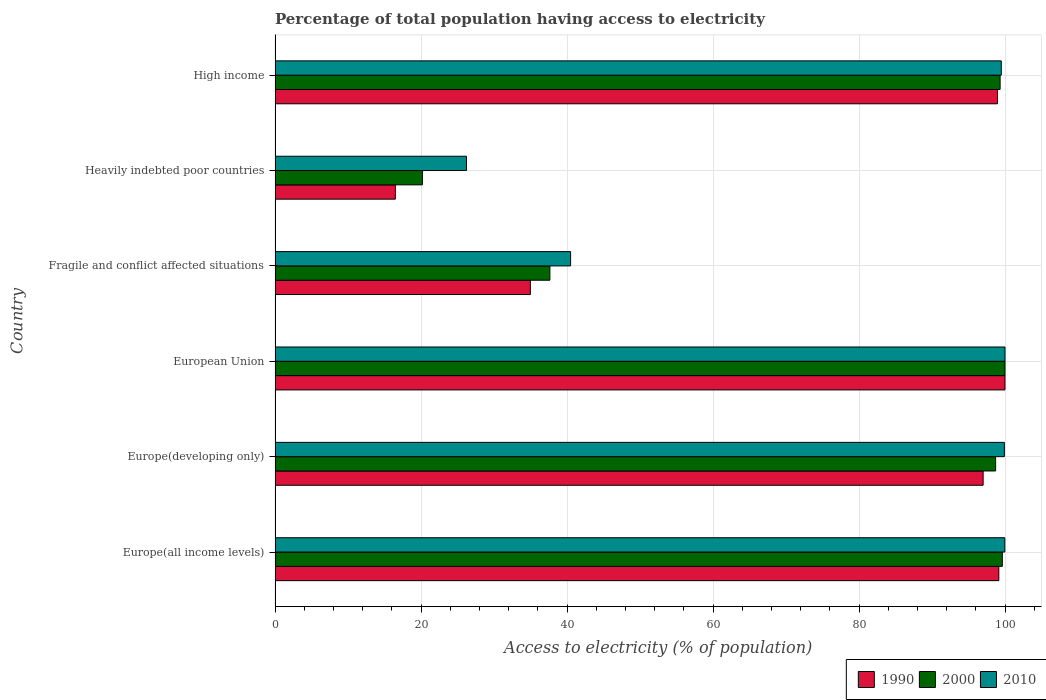Are the number of bars per tick equal to the number of legend labels?
Provide a short and direct response. Yes. How many bars are there on the 4th tick from the bottom?
Provide a short and direct response. 3. What is the label of the 5th group of bars from the top?
Provide a short and direct response. Europe(developing only). In how many cases, is the number of bars for a given country not equal to the number of legend labels?
Make the answer very short. 0. What is the percentage of population that have access to electricity in 2000 in Fragile and conflict affected situations?
Give a very brief answer. 37.65. Across all countries, what is the maximum percentage of population that have access to electricity in 1990?
Keep it short and to the point. 99.99. Across all countries, what is the minimum percentage of population that have access to electricity in 2010?
Offer a very short reply. 26.22. In which country was the percentage of population that have access to electricity in 2000 minimum?
Give a very brief answer. Heavily indebted poor countries. What is the total percentage of population that have access to electricity in 2000 in the graph?
Your answer should be compact. 455.51. What is the difference between the percentage of population that have access to electricity in 2000 in Europe(all income levels) and that in Heavily indebted poor countries?
Give a very brief answer. 79.45. What is the difference between the percentage of population that have access to electricity in 2000 in High income and the percentage of population that have access to electricity in 1990 in Fragile and conflict affected situations?
Your answer should be compact. 64.36. What is the average percentage of population that have access to electricity in 1990 per country?
Your response must be concise. 74.43. What is the difference between the percentage of population that have access to electricity in 2010 and percentage of population that have access to electricity in 1990 in Heavily indebted poor countries?
Make the answer very short. 9.74. What is the ratio of the percentage of population that have access to electricity in 2000 in Europe(all income levels) to that in Fragile and conflict affected situations?
Your answer should be compact. 2.65. What is the difference between the highest and the second highest percentage of population that have access to electricity in 2000?
Keep it short and to the point. 0.37. What is the difference between the highest and the lowest percentage of population that have access to electricity in 1990?
Your response must be concise. 83.51. In how many countries, is the percentage of population that have access to electricity in 2010 greater than the average percentage of population that have access to electricity in 2010 taken over all countries?
Provide a short and direct response. 4. Is the sum of the percentage of population that have access to electricity in 1990 in European Union and Heavily indebted poor countries greater than the maximum percentage of population that have access to electricity in 2000 across all countries?
Offer a very short reply. Yes. Is it the case that in every country, the sum of the percentage of population that have access to electricity in 1990 and percentage of population that have access to electricity in 2010 is greater than the percentage of population that have access to electricity in 2000?
Ensure brevity in your answer.  Yes. Are all the bars in the graph horizontal?
Make the answer very short. Yes. Does the graph contain grids?
Offer a terse response. Yes. How many legend labels are there?
Your answer should be very brief. 3. What is the title of the graph?
Offer a very short reply. Percentage of total population having access to electricity. What is the label or title of the X-axis?
Provide a succinct answer. Access to electricity (% of population). What is the label or title of the Y-axis?
Ensure brevity in your answer.  Country. What is the Access to electricity (% of population) in 1990 in Europe(all income levels)?
Ensure brevity in your answer.  99.15. What is the Access to electricity (% of population) in 2000 in Europe(all income levels)?
Make the answer very short. 99.63. What is the Access to electricity (% of population) of 2010 in Europe(all income levels)?
Provide a short and direct response. 99.97. What is the Access to electricity (% of population) of 1990 in Europe(developing only)?
Your answer should be very brief. 97. What is the Access to electricity (% of population) in 2000 in Europe(developing only)?
Offer a terse response. 98.72. What is the Access to electricity (% of population) of 2010 in Europe(developing only)?
Your response must be concise. 99.91. What is the Access to electricity (% of population) of 1990 in European Union?
Your answer should be very brief. 99.99. What is the Access to electricity (% of population) in 2010 in European Union?
Make the answer very short. 100. What is the Access to electricity (% of population) in 1990 in Fragile and conflict affected situations?
Make the answer very short. 34.97. What is the Access to electricity (% of population) of 2000 in Fragile and conflict affected situations?
Your answer should be very brief. 37.65. What is the Access to electricity (% of population) in 2010 in Fragile and conflict affected situations?
Offer a very short reply. 40.49. What is the Access to electricity (% of population) of 1990 in Heavily indebted poor countries?
Provide a short and direct response. 16.48. What is the Access to electricity (% of population) in 2000 in Heavily indebted poor countries?
Ensure brevity in your answer.  20.18. What is the Access to electricity (% of population) in 2010 in Heavily indebted poor countries?
Give a very brief answer. 26.22. What is the Access to electricity (% of population) in 1990 in High income?
Keep it short and to the point. 98.97. What is the Access to electricity (% of population) of 2000 in High income?
Provide a succinct answer. 99.33. What is the Access to electricity (% of population) in 2010 in High income?
Offer a terse response. 99.49. Across all countries, what is the maximum Access to electricity (% of population) in 1990?
Provide a short and direct response. 99.99. Across all countries, what is the minimum Access to electricity (% of population) of 1990?
Offer a terse response. 16.48. Across all countries, what is the minimum Access to electricity (% of population) of 2000?
Your answer should be very brief. 20.18. Across all countries, what is the minimum Access to electricity (% of population) of 2010?
Offer a very short reply. 26.22. What is the total Access to electricity (% of population) of 1990 in the graph?
Ensure brevity in your answer.  446.58. What is the total Access to electricity (% of population) in 2000 in the graph?
Provide a succinct answer. 455.51. What is the total Access to electricity (% of population) in 2010 in the graph?
Your answer should be very brief. 466.09. What is the difference between the Access to electricity (% of population) of 1990 in Europe(all income levels) and that in Europe(developing only)?
Your response must be concise. 2.15. What is the difference between the Access to electricity (% of population) in 2000 in Europe(all income levels) and that in Europe(developing only)?
Provide a succinct answer. 0.92. What is the difference between the Access to electricity (% of population) in 2010 in Europe(all income levels) and that in Europe(developing only)?
Provide a short and direct response. 0.06. What is the difference between the Access to electricity (% of population) of 1990 in Europe(all income levels) and that in European Union?
Give a very brief answer. -0.84. What is the difference between the Access to electricity (% of population) of 2000 in Europe(all income levels) and that in European Union?
Your answer should be compact. -0.37. What is the difference between the Access to electricity (% of population) in 2010 in Europe(all income levels) and that in European Union?
Offer a very short reply. -0.03. What is the difference between the Access to electricity (% of population) in 1990 in Europe(all income levels) and that in Fragile and conflict affected situations?
Ensure brevity in your answer.  64.18. What is the difference between the Access to electricity (% of population) in 2000 in Europe(all income levels) and that in Fragile and conflict affected situations?
Make the answer very short. 61.98. What is the difference between the Access to electricity (% of population) in 2010 in Europe(all income levels) and that in Fragile and conflict affected situations?
Your answer should be compact. 59.49. What is the difference between the Access to electricity (% of population) of 1990 in Europe(all income levels) and that in Heavily indebted poor countries?
Offer a terse response. 82.67. What is the difference between the Access to electricity (% of population) in 2000 in Europe(all income levels) and that in Heavily indebted poor countries?
Offer a very short reply. 79.45. What is the difference between the Access to electricity (% of population) of 2010 in Europe(all income levels) and that in Heavily indebted poor countries?
Your response must be concise. 73.75. What is the difference between the Access to electricity (% of population) in 1990 in Europe(all income levels) and that in High income?
Provide a short and direct response. 0.18. What is the difference between the Access to electricity (% of population) of 2000 in Europe(all income levels) and that in High income?
Your answer should be very brief. 0.3. What is the difference between the Access to electricity (% of population) in 2010 in Europe(all income levels) and that in High income?
Offer a very short reply. 0.48. What is the difference between the Access to electricity (% of population) of 1990 in Europe(developing only) and that in European Union?
Your answer should be very brief. -2.99. What is the difference between the Access to electricity (% of population) in 2000 in Europe(developing only) and that in European Union?
Provide a succinct answer. -1.28. What is the difference between the Access to electricity (% of population) of 2010 in Europe(developing only) and that in European Union?
Give a very brief answer. -0.09. What is the difference between the Access to electricity (% of population) of 1990 in Europe(developing only) and that in Fragile and conflict affected situations?
Your response must be concise. 62.03. What is the difference between the Access to electricity (% of population) of 2000 in Europe(developing only) and that in Fragile and conflict affected situations?
Make the answer very short. 61.07. What is the difference between the Access to electricity (% of population) in 2010 in Europe(developing only) and that in Fragile and conflict affected situations?
Offer a terse response. 59.42. What is the difference between the Access to electricity (% of population) in 1990 in Europe(developing only) and that in Heavily indebted poor countries?
Your answer should be very brief. 80.52. What is the difference between the Access to electricity (% of population) in 2000 in Europe(developing only) and that in Heavily indebted poor countries?
Ensure brevity in your answer.  78.53. What is the difference between the Access to electricity (% of population) in 2010 in Europe(developing only) and that in Heavily indebted poor countries?
Provide a succinct answer. 73.69. What is the difference between the Access to electricity (% of population) in 1990 in Europe(developing only) and that in High income?
Offer a terse response. -1.97. What is the difference between the Access to electricity (% of population) of 2000 in Europe(developing only) and that in High income?
Keep it short and to the point. -0.62. What is the difference between the Access to electricity (% of population) in 2010 in Europe(developing only) and that in High income?
Your response must be concise. 0.42. What is the difference between the Access to electricity (% of population) of 1990 in European Union and that in Fragile and conflict affected situations?
Give a very brief answer. 65.02. What is the difference between the Access to electricity (% of population) of 2000 in European Union and that in Fragile and conflict affected situations?
Provide a short and direct response. 62.35. What is the difference between the Access to electricity (% of population) of 2010 in European Union and that in Fragile and conflict affected situations?
Provide a short and direct response. 59.51. What is the difference between the Access to electricity (% of population) of 1990 in European Union and that in Heavily indebted poor countries?
Offer a terse response. 83.51. What is the difference between the Access to electricity (% of population) in 2000 in European Union and that in Heavily indebted poor countries?
Your response must be concise. 79.82. What is the difference between the Access to electricity (% of population) in 2010 in European Union and that in Heavily indebted poor countries?
Provide a short and direct response. 73.78. What is the difference between the Access to electricity (% of population) in 1990 in European Union and that in High income?
Your response must be concise. 1.02. What is the difference between the Access to electricity (% of population) in 2000 in European Union and that in High income?
Keep it short and to the point. 0.67. What is the difference between the Access to electricity (% of population) in 2010 in European Union and that in High income?
Offer a very short reply. 0.51. What is the difference between the Access to electricity (% of population) in 1990 in Fragile and conflict affected situations and that in Heavily indebted poor countries?
Provide a short and direct response. 18.49. What is the difference between the Access to electricity (% of population) in 2000 in Fragile and conflict affected situations and that in Heavily indebted poor countries?
Your response must be concise. 17.46. What is the difference between the Access to electricity (% of population) of 2010 in Fragile and conflict affected situations and that in Heavily indebted poor countries?
Give a very brief answer. 14.27. What is the difference between the Access to electricity (% of population) in 1990 in Fragile and conflict affected situations and that in High income?
Your response must be concise. -64. What is the difference between the Access to electricity (% of population) of 2000 in Fragile and conflict affected situations and that in High income?
Your answer should be compact. -61.68. What is the difference between the Access to electricity (% of population) of 2010 in Fragile and conflict affected situations and that in High income?
Make the answer very short. -59.01. What is the difference between the Access to electricity (% of population) of 1990 in Heavily indebted poor countries and that in High income?
Keep it short and to the point. -82.49. What is the difference between the Access to electricity (% of population) in 2000 in Heavily indebted poor countries and that in High income?
Your answer should be compact. -79.15. What is the difference between the Access to electricity (% of population) of 2010 in Heavily indebted poor countries and that in High income?
Your answer should be very brief. -73.27. What is the difference between the Access to electricity (% of population) of 1990 in Europe(all income levels) and the Access to electricity (% of population) of 2000 in Europe(developing only)?
Keep it short and to the point. 0.44. What is the difference between the Access to electricity (% of population) in 1990 in Europe(all income levels) and the Access to electricity (% of population) in 2010 in Europe(developing only)?
Make the answer very short. -0.76. What is the difference between the Access to electricity (% of population) of 2000 in Europe(all income levels) and the Access to electricity (% of population) of 2010 in Europe(developing only)?
Provide a short and direct response. -0.28. What is the difference between the Access to electricity (% of population) in 1990 in Europe(all income levels) and the Access to electricity (% of population) in 2000 in European Union?
Provide a succinct answer. -0.85. What is the difference between the Access to electricity (% of population) in 1990 in Europe(all income levels) and the Access to electricity (% of population) in 2010 in European Union?
Provide a short and direct response. -0.85. What is the difference between the Access to electricity (% of population) in 2000 in Europe(all income levels) and the Access to electricity (% of population) in 2010 in European Union?
Keep it short and to the point. -0.37. What is the difference between the Access to electricity (% of population) in 1990 in Europe(all income levels) and the Access to electricity (% of population) in 2000 in Fragile and conflict affected situations?
Give a very brief answer. 61.5. What is the difference between the Access to electricity (% of population) of 1990 in Europe(all income levels) and the Access to electricity (% of population) of 2010 in Fragile and conflict affected situations?
Keep it short and to the point. 58.67. What is the difference between the Access to electricity (% of population) of 2000 in Europe(all income levels) and the Access to electricity (% of population) of 2010 in Fragile and conflict affected situations?
Make the answer very short. 59.15. What is the difference between the Access to electricity (% of population) of 1990 in Europe(all income levels) and the Access to electricity (% of population) of 2000 in Heavily indebted poor countries?
Offer a terse response. 78.97. What is the difference between the Access to electricity (% of population) in 1990 in Europe(all income levels) and the Access to electricity (% of population) in 2010 in Heavily indebted poor countries?
Make the answer very short. 72.93. What is the difference between the Access to electricity (% of population) in 2000 in Europe(all income levels) and the Access to electricity (% of population) in 2010 in Heavily indebted poor countries?
Offer a very short reply. 73.41. What is the difference between the Access to electricity (% of population) of 1990 in Europe(all income levels) and the Access to electricity (% of population) of 2000 in High income?
Your answer should be very brief. -0.18. What is the difference between the Access to electricity (% of population) of 1990 in Europe(all income levels) and the Access to electricity (% of population) of 2010 in High income?
Keep it short and to the point. -0.34. What is the difference between the Access to electricity (% of population) of 2000 in Europe(all income levels) and the Access to electricity (% of population) of 2010 in High income?
Offer a terse response. 0.14. What is the difference between the Access to electricity (% of population) in 1990 in Europe(developing only) and the Access to electricity (% of population) in 2000 in European Union?
Offer a terse response. -3. What is the difference between the Access to electricity (% of population) in 1990 in Europe(developing only) and the Access to electricity (% of population) in 2010 in European Union?
Your response must be concise. -3. What is the difference between the Access to electricity (% of population) of 2000 in Europe(developing only) and the Access to electricity (% of population) of 2010 in European Union?
Provide a succinct answer. -1.28. What is the difference between the Access to electricity (% of population) in 1990 in Europe(developing only) and the Access to electricity (% of population) in 2000 in Fragile and conflict affected situations?
Your response must be concise. 59.36. What is the difference between the Access to electricity (% of population) in 1990 in Europe(developing only) and the Access to electricity (% of population) in 2010 in Fragile and conflict affected situations?
Ensure brevity in your answer.  56.52. What is the difference between the Access to electricity (% of population) of 2000 in Europe(developing only) and the Access to electricity (% of population) of 2010 in Fragile and conflict affected situations?
Your answer should be very brief. 58.23. What is the difference between the Access to electricity (% of population) of 1990 in Europe(developing only) and the Access to electricity (% of population) of 2000 in Heavily indebted poor countries?
Provide a short and direct response. 76.82. What is the difference between the Access to electricity (% of population) of 1990 in Europe(developing only) and the Access to electricity (% of population) of 2010 in Heavily indebted poor countries?
Provide a short and direct response. 70.78. What is the difference between the Access to electricity (% of population) in 2000 in Europe(developing only) and the Access to electricity (% of population) in 2010 in Heavily indebted poor countries?
Provide a succinct answer. 72.49. What is the difference between the Access to electricity (% of population) of 1990 in Europe(developing only) and the Access to electricity (% of population) of 2000 in High income?
Keep it short and to the point. -2.33. What is the difference between the Access to electricity (% of population) of 1990 in Europe(developing only) and the Access to electricity (% of population) of 2010 in High income?
Make the answer very short. -2.49. What is the difference between the Access to electricity (% of population) of 2000 in Europe(developing only) and the Access to electricity (% of population) of 2010 in High income?
Your response must be concise. -0.78. What is the difference between the Access to electricity (% of population) of 1990 in European Union and the Access to electricity (% of population) of 2000 in Fragile and conflict affected situations?
Your answer should be very brief. 62.35. What is the difference between the Access to electricity (% of population) of 1990 in European Union and the Access to electricity (% of population) of 2010 in Fragile and conflict affected situations?
Keep it short and to the point. 59.51. What is the difference between the Access to electricity (% of population) in 2000 in European Union and the Access to electricity (% of population) in 2010 in Fragile and conflict affected situations?
Provide a short and direct response. 59.51. What is the difference between the Access to electricity (% of population) in 1990 in European Union and the Access to electricity (% of population) in 2000 in Heavily indebted poor countries?
Offer a very short reply. 79.81. What is the difference between the Access to electricity (% of population) of 1990 in European Union and the Access to electricity (% of population) of 2010 in Heavily indebted poor countries?
Your answer should be very brief. 73.77. What is the difference between the Access to electricity (% of population) in 2000 in European Union and the Access to electricity (% of population) in 2010 in Heavily indebted poor countries?
Provide a succinct answer. 73.78. What is the difference between the Access to electricity (% of population) of 1990 in European Union and the Access to electricity (% of population) of 2000 in High income?
Your answer should be very brief. 0.66. What is the difference between the Access to electricity (% of population) of 1990 in European Union and the Access to electricity (% of population) of 2010 in High income?
Offer a very short reply. 0.5. What is the difference between the Access to electricity (% of population) of 2000 in European Union and the Access to electricity (% of population) of 2010 in High income?
Your answer should be compact. 0.51. What is the difference between the Access to electricity (% of population) of 1990 in Fragile and conflict affected situations and the Access to electricity (% of population) of 2000 in Heavily indebted poor countries?
Offer a very short reply. 14.79. What is the difference between the Access to electricity (% of population) of 1990 in Fragile and conflict affected situations and the Access to electricity (% of population) of 2010 in Heavily indebted poor countries?
Provide a succinct answer. 8.75. What is the difference between the Access to electricity (% of population) in 2000 in Fragile and conflict affected situations and the Access to electricity (% of population) in 2010 in Heavily indebted poor countries?
Provide a succinct answer. 11.43. What is the difference between the Access to electricity (% of population) of 1990 in Fragile and conflict affected situations and the Access to electricity (% of population) of 2000 in High income?
Your response must be concise. -64.36. What is the difference between the Access to electricity (% of population) in 1990 in Fragile and conflict affected situations and the Access to electricity (% of population) in 2010 in High income?
Your response must be concise. -64.52. What is the difference between the Access to electricity (% of population) in 2000 in Fragile and conflict affected situations and the Access to electricity (% of population) in 2010 in High income?
Your answer should be compact. -61.85. What is the difference between the Access to electricity (% of population) of 1990 in Heavily indebted poor countries and the Access to electricity (% of population) of 2000 in High income?
Ensure brevity in your answer.  -82.85. What is the difference between the Access to electricity (% of population) in 1990 in Heavily indebted poor countries and the Access to electricity (% of population) in 2010 in High income?
Give a very brief answer. -83.01. What is the difference between the Access to electricity (% of population) in 2000 in Heavily indebted poor countries and the Access to electricity (% of population) in 2010 in High income?
Provide a short and direct response. -79.31. What is the average Access to electricity (% of population) in 1990 per country?
Your answer should be very brief. 74.43. What is the average Access to electricity (% of population) in 2000 per country?
Provide a short and direct response. 75.92. What is the average Access to electricity (% of population) of 2010 per country?
Ensure brevity in your answer.  77.68. What is the difference between the Access to electricity (% of population) of 1990 and Access to electricity (% of population) of 2000 in Europe(all income levels)?
Give a very brief answer. -0.48. What is the difference between the Access to electricity (% of population) in 1990 and Access to electricity (% of population) in 2010 in Europe(all income levels)?
Offer a terse response. -0.82. What is the difference between the Access to electricity (% of population) in 2000 and Access to electricity (% of population) in 2010 in Europe(all income levels)?
Make the answer very short. -0.34. What is the difference between the Access to electricity (% of population) in 1990 and Access to electricity (% of population) in 2000 in Europe(developing only)?
Your answer should be compact. -1.71. What is the difference between the Access to electricity (% of population) of 1990 and Access to electricity (% of population) of 2010 in Europe(developing only)?
Ensure brevity in your answer.  -2.91. What is the difference between the Access to electricity (% of population) of 2000 and Access to electricity (% of population) of 2010 in Europe(developing only)?
Offer a very short reply. -1.2. What is the difference between the Access to electricity (% of population) in 1990 and Access to electricity (% of population) in 2000 in European Union?
Offer a very short reply. -0.01. What is the difference between the Access to electricity (% of population) of 1990 and Access to electricity (% of population) of 2010 in European Union?
Make the answer very short. -0.01. What is the difference between the Access to electricity (% of population) of 1990 and Access to electricity (% of population) of 2000 in Fragile and conflict affected situations?
Provide a succinct answer. -2.68. What is the difference between the Access to electricity (% of population) in 1990 and Access to electricity (% of population) in 2010 in Fragile and conflict affected situations?
Provide a succinct answer. -5.51. What is the difference between the Access to electricity (% of population) of 2000 and Access to electricity (% of population) of 2010 in Fragile and conflict affected situations?
Your response must be concise. -2.84. What is the difference between the Access to electricity (% of population) of 1990 and Access to electricity (% of population) of 2000 in Heavily indebted poor countries?
Offer a terse response. -3.7. What is the difference between the Access to electricity (% of population) in 1990 and Access to electricity (% of population) in 2010 in Heavily indebted poor countries?
Offer a very short reply. -9.74. What is the difference between the Access to electricity (% of population) of 2000 and Access to electricity (% of population) of 2010 in Heavily indebted poor countries?
Make the answer very short. -6.04. What is the difference between the Access to electricity (% of population) of 1990 and Access to electricity (% of population) of 2000 in High income?
Provide a short and direct response. -0.36. What is the difference between the Access to electricity (% of population) in 1990 and Access to electricity (% of population) in 2010 in High income?
Make the answer very short. -0.52. What is the difference between the Access to electricity (% of population) of 2000 and Access to electricity (% of population) of 2010 in High income?
Provide a short and direct response. -0.16. What is the ratio of the Access to electricity (% of population) of 1990 in Europe(all income levels) to that in Europe(developing only)?
Offer a very short reply. 1.02. What is the ratio of the Access to electricity (% of population) in 2000 in Europe(all income levels) to that in Europe(developing only)?
Make the answer very short. 1.01. What is the ratio of the Access to electricity (% of population) in 2010 in Europe(all income levels) to that in Europe(developing only)?
Your answer should be compact. 1. What is the ratio of the Access to electricity (% of population) in 1990 in Europe(all income levels) to that in European Union?
Offer a terse response. 0.99. What is the ratio of the Access to electricity (% of population) of 2010 in Europe(all income levels) to that in European Union?
Give a very brief answer. 1. What is the ratio of the Access to electricity (% of population) of 1990 in Europe(all income levels) to that in Fragile and conflict affected situations?
Make the answer very short. 2.84. What is the ratio of the Access to electricity (% of population) of 2000 in Europe(all income levels) to that in Fragile and conflict affected situations?
Offer a very short reply. 2.65. What is the ratio of the Access to electricity (% of population) of 2010 in Europe(all income levels) to that in Fragile and conflict affected situations?
Keep it short and to the point. 2.47. What is the ratio of the Access to electricity (% of population) in 1990 in Europe(all income levels) to that in Heavily indebted poor countries?
Give a very brief answer. 6.02. What is the ratio of the Access to electricity (% of population) in 2000 in Europe(all income levels) to that in Heavily indebted poor countries?
Keep it short and to the point. 4.94. What is the ratio of the Access to electricity (% of population) of 2010 in Europe(all income levels) to that in Heavily indebted poor countries?
Give a very brief answer. 3.81. What is the ratio of the Access to electricity (% of population) of 2000 in Europe(all income levels) to that in High income?
Provide a short and direct response. 1. What is the ratio of the Access to electricity (% of population) in 1990 in Europe(developing only) to that in European Union?
Keep it short and to the point. 0.97. What is the ratio of the Access to electricity (% of population) of 2000 in Europe(developing only) to that in European Union?
Offer a terse response. 0.99. What is the ratio of the Access to electricity (% of population) of 2010 in Europe(developing only) to that in European Union?
Your answer should be compact. 1. What is the ratio of the Access to electricity (% of population) in 1990 in Europe(developing only) to that in Fragile and conflict affected situations?
Give a very brief answer. 2.77. What is the ratio of the Access to electricity (% of population) of 2000 in Europe(developing only) to that in Fragile and conflict affected situations?
Your answer should be very brief. 2.62. What is the ratio of the Access to electricity (% of population) of 2010 in Europe(developing only) to that in Fragile and conflict affected situations?
Offer a terse response. 2.47. What is the ratio of the Access to electricity (% of population) of 1990 in Europe(developing only) to that in Heavily indebted poor countries?
Keep it short and to the point. 5.89. What is the ratio of the Access to electricity (% of population) of 2000 in Europe(developing only) to that in Heavily indebted poor countries?
Your answer should be compact. 4.89. What is the ratio of the Access to electricity (% of population) in 2010 in Europe(developing only) to that in Heavily indebted poor countries?
Your response must be concise. 3.81. What is the ratio of the Access to electricity (% of population) in 1990 in Europe(developing only) to that in High income?
Your response must be concise. 0.98. What is the ratio of the Access to electricity (% of population) of 2010 in Europe(developing only) to that in High income?
Offer a very short reply. 1. What is the ratio of the Access to electricity (% of population) in 1990 in European Union to that in Fragile and conflict affected situations?
Keep it short and to the point. 2.86. What is the ratio of the Access to electricity (% of population) in 2000 in European Union to that in Fragile and conflict affected situations?
Provide a short and direct response. 2.66. What is the ratio of the Access to electricity (% of population) of 2010 in European Union to that in Fragile and conflict affected situations?
Provide a short and direct response. 2.47. What is the ratio of the Access to electricity (% of population) of 1990 in European Union to that in Heavily indebted poor countries?
Make the answer very short. 6.07. What is the ratio of the Access to electricity (% of population) in 2000 in European Union to that in Heavily indebted poor countries?
Offer a terse response. 4.95. What is the ratio of the Access to electricity (% of population) in 2010 in European Union to that in Heavily indebted poor countries?
Make the answer very short. 3.81. What is the ratio of the Access to electricity (% of population) in 1990 in European Union to that in High income?
Provide a succinct answer. 1.01. What is the ratio of the Access to electricity (% of population) of 2000 in European Union to that in High income?
Provide a succinct answer. 1.01. What is the ratio of the Access to electricity (% of population) of 2010 in European Union to that in High income?
Your answer should be compact. 1.01. What is the ratio of the Access to electricity (% of population) in 1990 in Fragile and conflict affected situations to that in Heavily indebted poor countries?
Your response must be concise. 2.12. What is the ratio of the Access to electricity (% of population) of 2000 in Fragile and conflict affected situations to that in Heavily indebted poor countries?
Give a very brief answer. 1.87. What is the ratio of the Access to electricity (% of population) of 2010 in Fragile and conflict affected situations to that in Heavily indebted poor countries?
Offer a terse response. 1.54. What is the ratio of the Access to electricity (% of population) of 1990 in Fragile and conflict affected situations to that in High income?
Provide a succinct answer. 0.35. What is the ratio of the Access to electricity (% of population) in 2000 in Fragile and conflict affected situations to that in High income?
Provide a short and direct response. 0.38. What is the ratio of the Access to electricity (% of population) of 2010 in Fragile and conflict affected situations to that in High income?
Offer a terse response. 0.41. What is the ratio of the Access to electricity (% of population) in 1990 in Heavily indebted poor countries to that in High income?
Your response must be concise. 0.17. What is the ratio of the Access to electricity (% of population) of 2000 in Heavily indebted poor countries to that in High income?
Your response must be concise. 0.2. What is the ratio of the Access to electricity (% of population) in 2010 in Heavily indebted poor countries to that in High income?
Make the answer very short. 0.26. What is the difference between the highest and the second highest Access to electricity (% of population) in 1990?
Make the answer very short. 0.84. What is the difference between the highest and the second highest Access to electricity (% of population) in 2000?
Your answer should be compact. 0.37. What is the difference between the highest and the second highest Access to electricity (% of population) of 2010?
Keep it short and to the point. 0.03. What is the difference between the highest and the lowest Access to electricity (% of population) in 1990?
Offer a terse response. 83.51. What is the difference between the highest and the lowest Access to electricity (% of population) in 2000?
Your response must be concise. 79.82. What is the difference between the highest and the lowest Access to electricity (% of population) of 2010?
Keep it short and to the point. 73.78. 